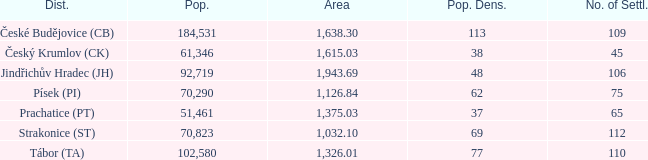How big is the area that has a population density of 113 and a population larger than 184,531? 0.0. 